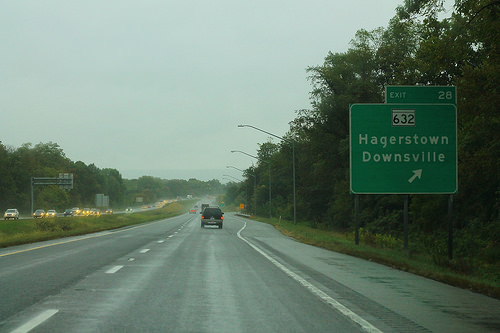<image>
Can you confirm if the vehicle is in front of the road sign? Yes. The vehicle is positioned in front of the road sign, appearing closer to the camera viewpoint. 